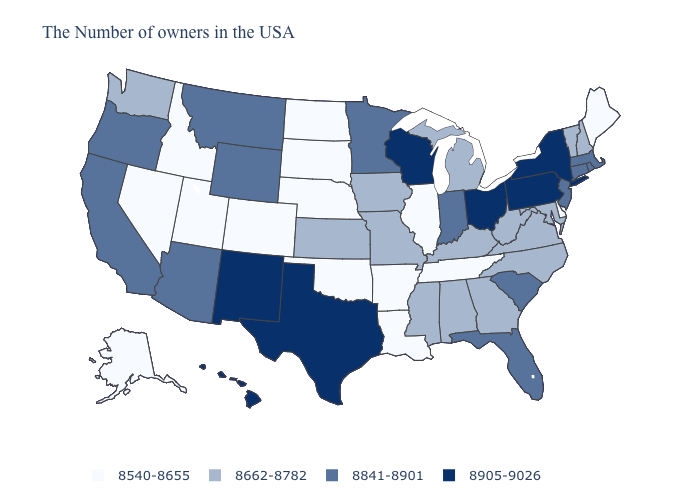What is the value of Maine?
Concise answer only. 8540-8655. Which states hav the highest value in the Northeast?
Short answer required. New York, Pennsylvania. Name the states that have a value in the range 8905-9026?
Give a very brief answer. New York, Pennsylvania, Ohio, Wisconsin, Texas, New Mexico, Hawaii. Which states have the highest value in the USA?
Be succinct. New York, Pennsylvania, Ohio, Wisconsin, Texas, New Mexico, Hawaii. Which states hav the highest value in the MidWest?
Quick response, please. Ohio, Wisconsin. Name the states that have a value in the range 8540-8655?
Answer briefly. Maine, Delaware, Tennessee, Illinois, Louisiana, Arkansas, Nebraska, Oklahoma, South Dakota, North Dakota, Colorado, Utah, Idaho, Nevada, Alaska. Name the states that have a value in the range 8841-8901?
Quick response, please. Massachusetts, Rhode Island, Connecticut, New Jersey, South Carolina, Florida, Indiana, Minnesota, Wyoming, Montana, Arizona, California, Oregon. Name the states that have a value in the range 8540-8655?
Short answer required. Maine, Delaware, Tennessee, Illinois, Louisiana, Arkansas, Nebraska, Oklahoma, South Dakota, North Dakota, Colorado, Utah, Idaho, Nevada, Alaska. What is the value of New Jersey?
Write a very short answer. 8841-8901. What is the lowest value in the Northeast?
Quick response, please. 8540-8655. Which states have the lowest value in the USA?
Concise answer only. Maine, Delaware, Tennessee, Illinois, Louisiana, Arkansas, Nebraska, Oklahoma, South Dakota, North Dakota, Colorado, Utah, Idaho, Nevada, Alaska. Among the states that border Delaware , which have the lowest value?
Give a very brief answer. Maryland. Does Texas have the same value as Illinois?
Short answer required. No. Name the states that have a value in the range 8905-9026?
Short answer required. New York, Pennsylvania, Ohio, Wisconsin, Texas, New Mexico, Hawaii. What is the value of Alaska?
Concise answer only. 8540-8655. 